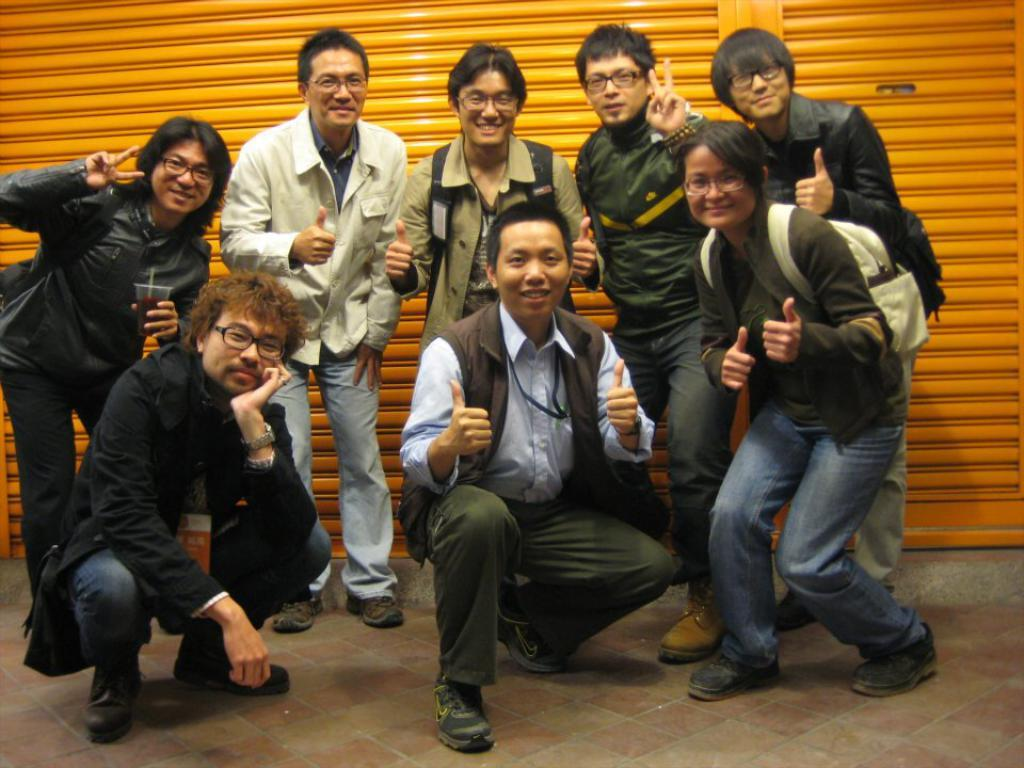What is the main subject of the image? There is a group of people in the middle of the image. Can you describe the background of the image? There are shutters in the background of the image. Can you tell me how many birds are swimming in the town depicted in the image? There are no birds or town present in the image; it features a group of people and shutters in the background. 